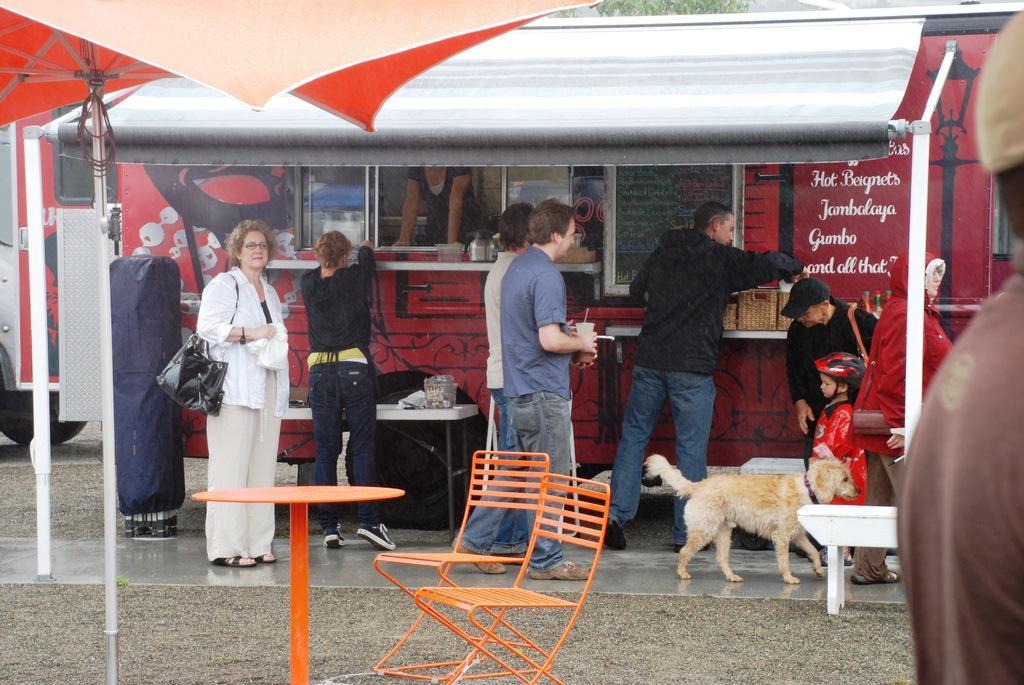Could you give a brief overview of what you see in this image? In this image there are some persons who are standing at the food court and at the foreground of the image there are chairs and table. 